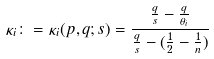Convert formula to latex. <formula><loc_0><loc_0><loc_500><loc_500>\kappa _ { i } \colon = \kappa _ { i } ( p , q ; s ) = \frac { \frac { q } { s } - \frac { q } { \theta _ { i } } } { \frac { q } { s } - ( \frac { 1 } { 2 } - \frac { 1 } { n } ) }</formula> 